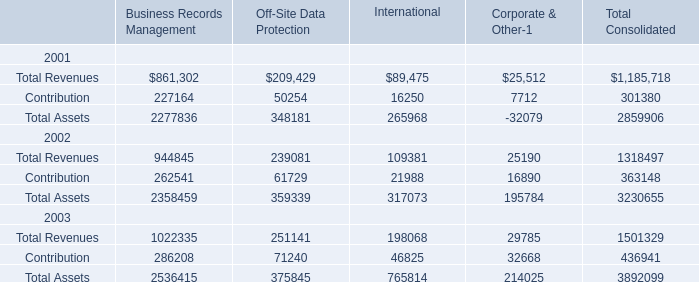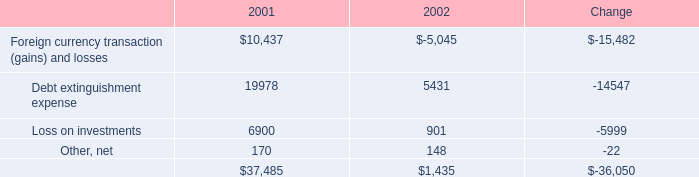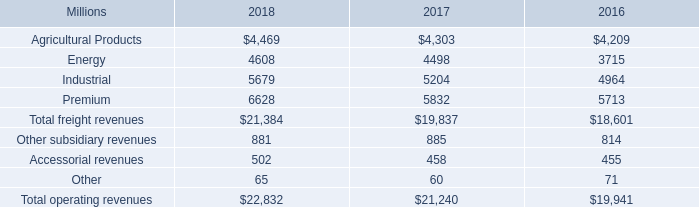What's the sum of Agricultural Products of 2016, and Contribution of Business Records Management ? 
Computations: (4209.0 + 227164.0)
Answer: 231373.0. 